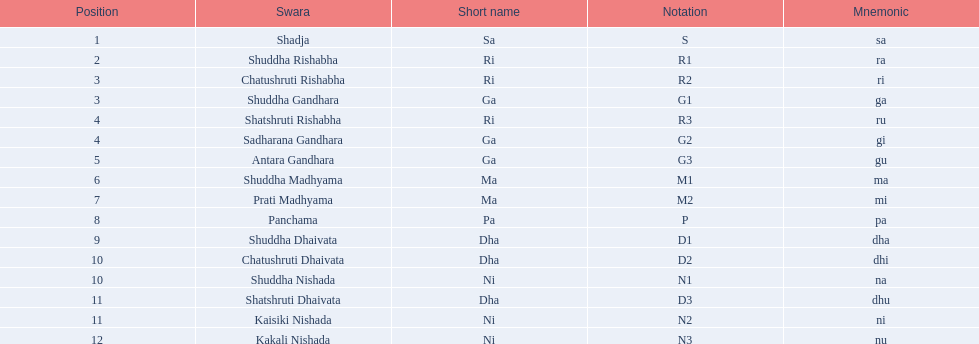What is the total amount of positions specified? 16. 